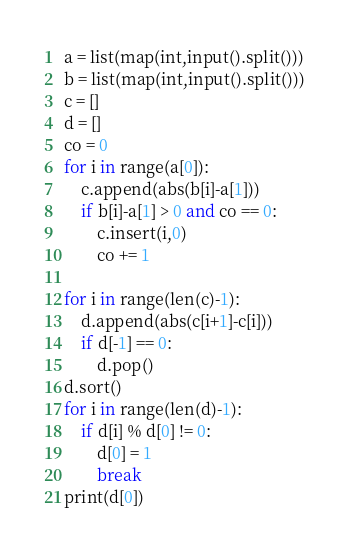Convert code to text. <code><loc_0><loc_0><loc_500><loc_500><_Python_>a = list(map(int,input().split()))
b = list(map(int,input().split()))
c = []
d = []
co = 0
for i in range(a[0]):
	c.append(abs(b[i]-a[1]))
	if b[i]-a[1] > 0 and co == 0:
		c.insert(i,0)
		co += 1

for i in range(len(c)-1):
	d.append(abs(c[i+1]-c[i]))
	if d[-1] == 0:
		d.pop()
d.sort()
for i in range(len(d)-1):
	if d[i] % d[0] != 0:
		d[0] = 1
		break
print(d[0])</code> 